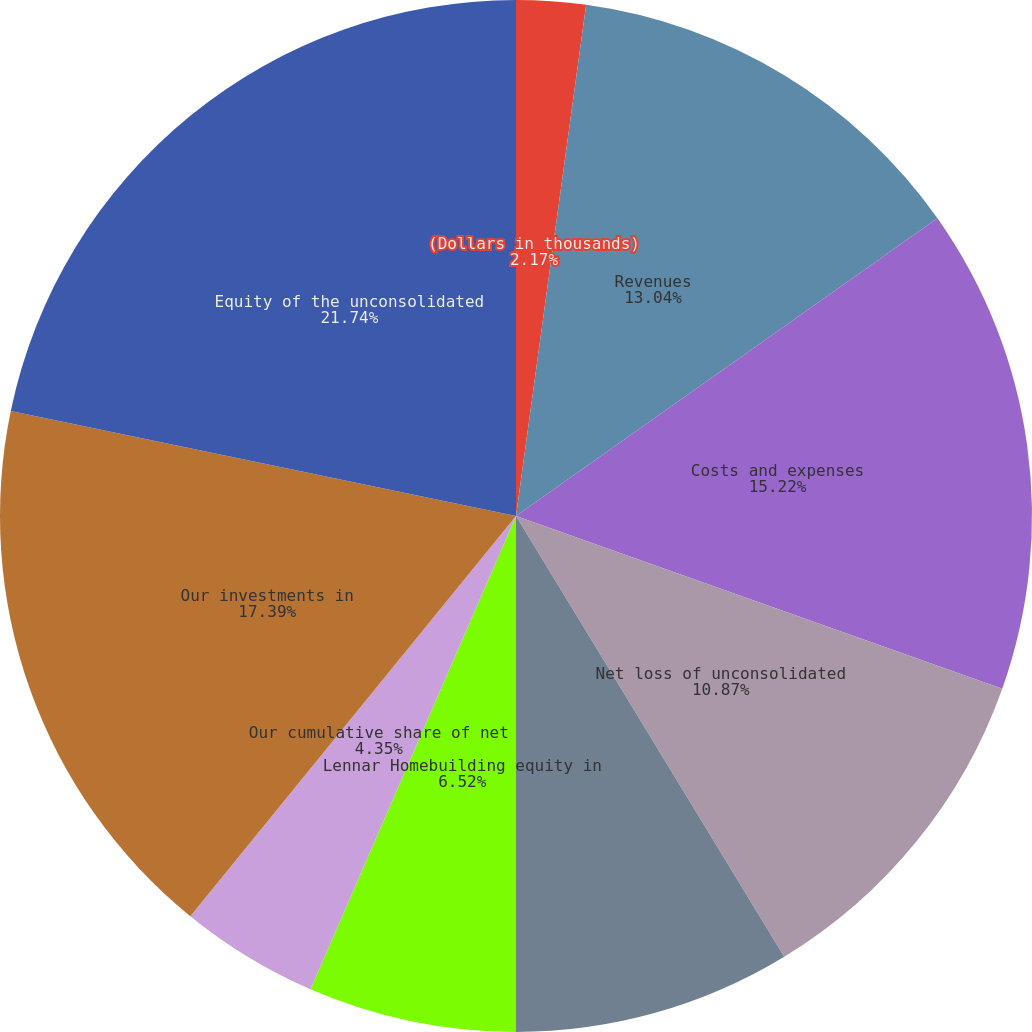Convert chart. <chart><loc_0><loc_0><loc_500><loc_500><pie_chart><fcel>(Dollars in thousands)<fcel>Revenues<fcel>Costs and expenses<fcel>Net loss of unconsolidated<fcel>Our share of net loss<fcel>Lennar Homebuilding equity in<fcel>Our cumulative share of net<fcel>Our investments in<fcel>Equity of the unconsolidated<fcel>Our investment in the<nl><fcel>2.17%<fcel>13.04%<fcel>15.22%<fcel>10.87%<fcel>8.7%<fcel>6.52%<fcel>4.35%<fcel>17.39%<fcel>21.74%<fcel>0.0%<nl></chart> 